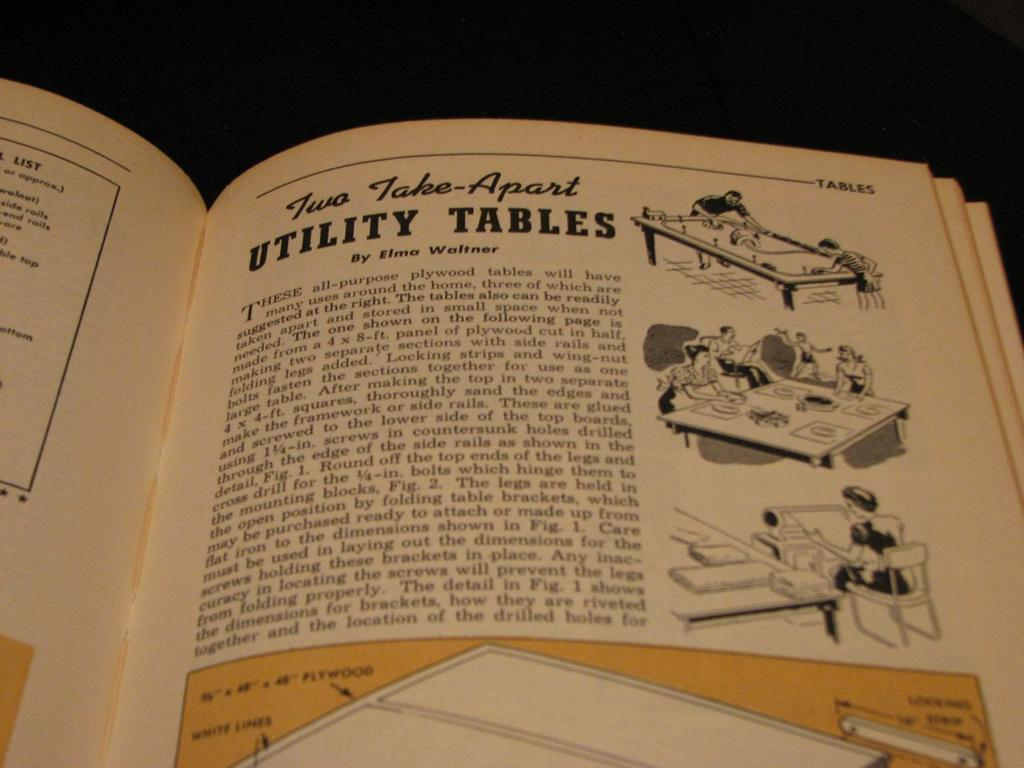<image>
Give a short and clear explanation of the subsequent image. an open book with a page titled 'two take-apart utility tables' 